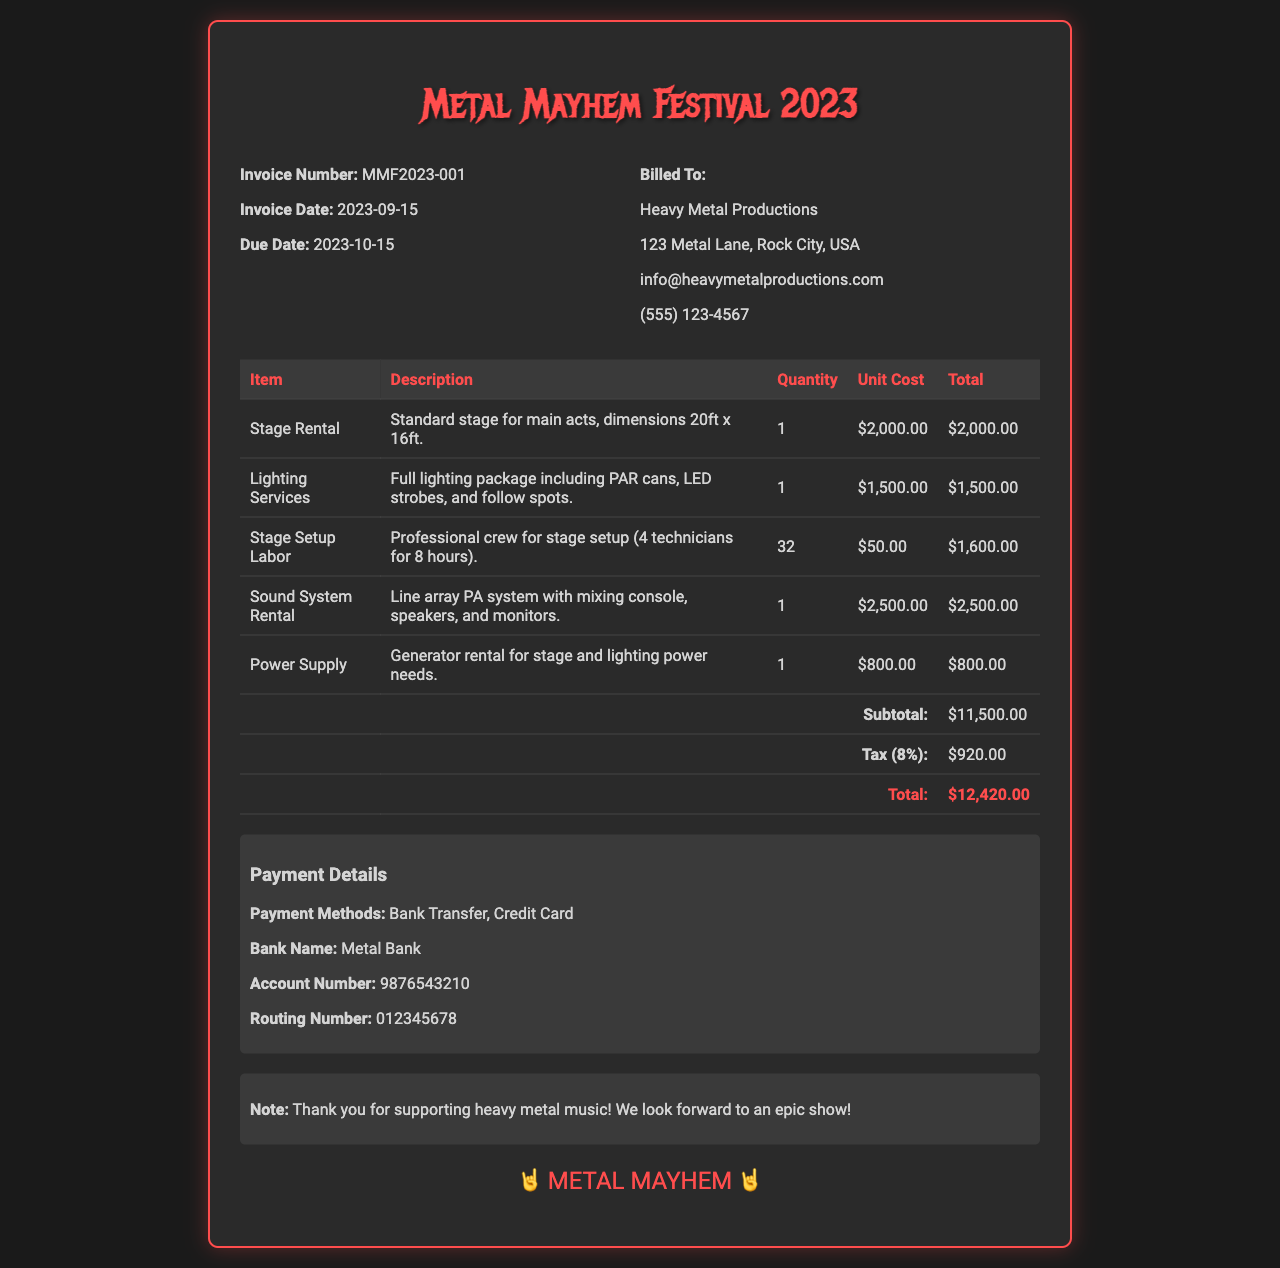What is the invoice number? The invoice number is listed at the top of the document, under the invoice details section.
Answer: MMF2023-001 What is the total amount due? The total amount due is found at the bottom of the itemized costs table.
Answer: $12,420.00 What date is the invoice due? The due date is specified in the invoice details section.
Answer: 2023-10-15 How many technicians are included for stage setup? The number of technicians is mentioned in the description for the stage setup labor.
Answer: 4 What item costs $2,500.00? The item with this cost can be found in the itemized list of services.
Answer: Sound System Rental What percentage is the tax applied on the subtotal? The tax percentage is mentioned right before the tax amount in the invoice.
Answer: 8% What is the subtotal amount before tax? The subtotal amount is provided in the itemized cost section before the tax calculation.
Answer: $11,500.00 What payment methods are accepted? The document specifies the payment methods under the payment details section.
Answer: Bank Transfer, Credit Card What is the name of the bank for payment? The bank name is clearly stated in the payment details section of the invoice.
Answer: Metal Bank 